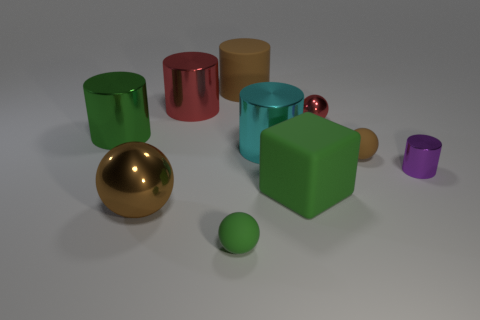Subtract 2 cylinders. How many cylinders are left? 3 Subtract all purple metal cylinders. How many cylinders are left? 4 Subtract all cyan cylinders. How many cylinders are left? 4 Subtract all gray cylinders. Subtract all red spheres. How many cylinders are left? 5 Subtract all blocks. How many objects are left? 9 Subtract 0 yellow cylinders. How many objects are left? 10 Subtract all tiny cyan metallic cylinders. Subtract all shiny cylinders. How many objects are left? 6 Add 1 green metallic objects. How many green metallic objects are left? 2 Add 10 green metallic blocks. How many green metallic blocks exist? 10 